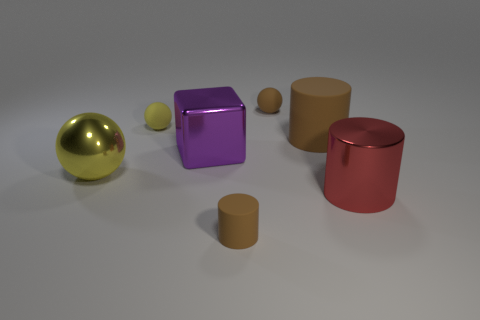What is the size of the other cylinder that is the same color as the tiny cylinder?
Keep it short and to the point. Large. What number of other things are the same size as the yellow metal thing?
Ensure brevity in your answer.  3. Are the yellow ball in front of the large purple shiny thing and the big block made of the same material?
Make the answer very short. Yes. What number of other things are there of the same color as the big block?
Keep it short and to the point. 0. How many other things are there of the same shape as the large brown thing?
Keep it short and to the point. 2. Does the brown matte thing in front of the big red object have the same shape as the large thing that is to the left of the large metallic cube?
Your response must be concise. No. Is the number of small cylinders that are behind the purple object the same as the number of red cylinders behind the big red thing?
Offer a terse response. Yes. There is a yellow thing that is behind the brown matte cylinder that is behind the object that is in front of the big red metallic object; what is its shape?
Offer a terse response. Sphere. Are the brown cylinder behind the yellow metallic thing and the small brown thing that is in front of the purple object made of the same material?
Your response must be concise. Yes. What shape is the big metal thing behind the yellow metallic ball?
Provide a succinct answer. Cube. 